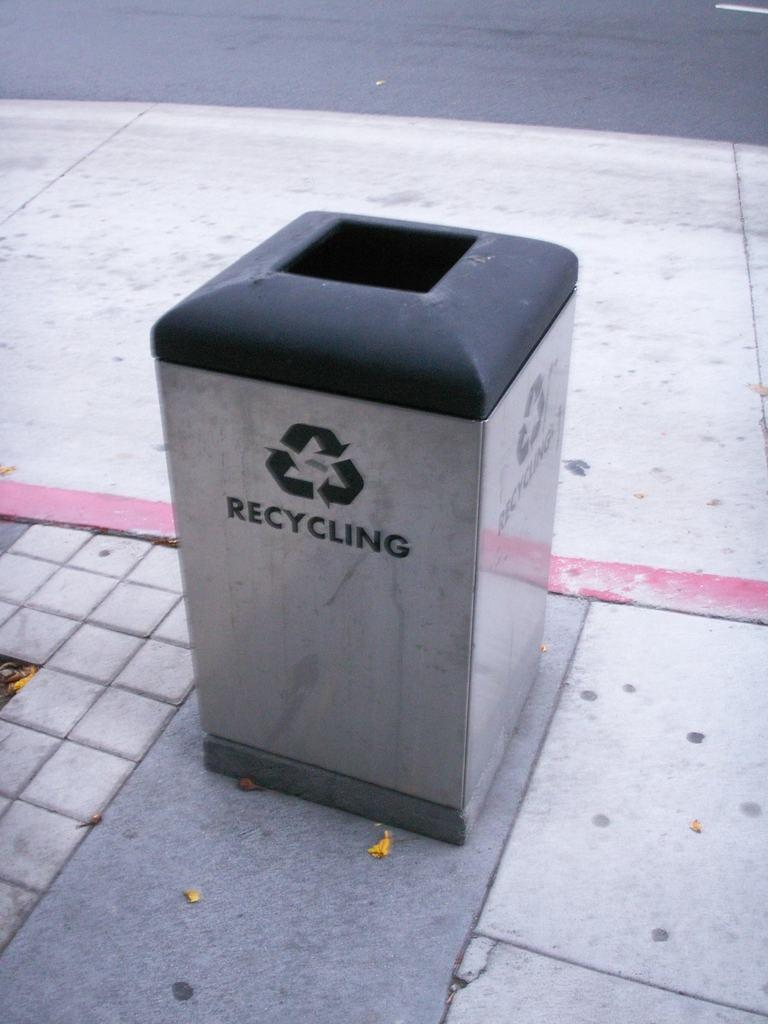<image>
Render a clear and concise summary of the photo. A silver recycling can is on a street with a black rim. 